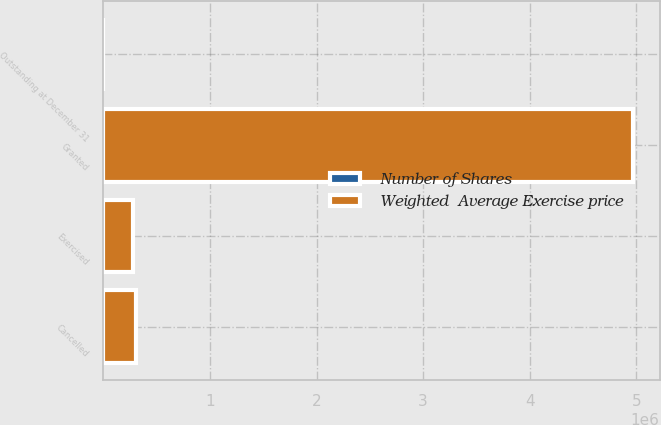Convert chart. <chart><loc_0><loc_0><loc_500><loc_500><stacked_bar_chart><ecel><fcel>Outstanding at December 31<fcel>Granted<fcel>Exercised<fcel>Cancelled<nl><fcel>Weighted  Average Exercise price<fcel>45.27<fcel>4.9705e+06<fcel>273382<fcel>308792<nl><fcel>Number of Shares<fcel>35.01<fcel>27.62<fcel>15.89<fcel>45.27<nl></chart> 